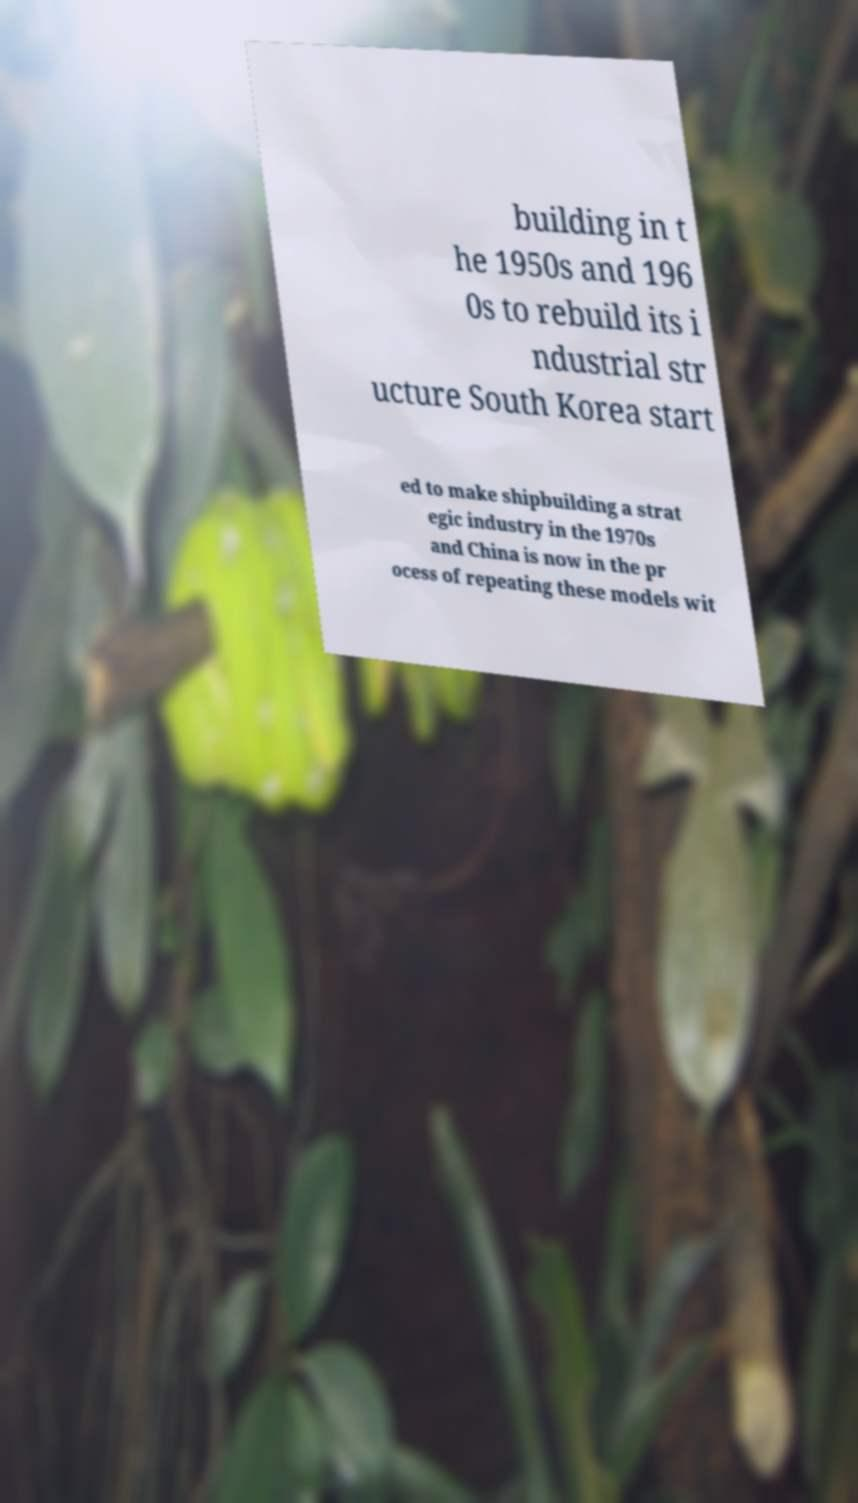For documentation purposes, I need the text within this image transcribed. Could you provide that? building in t he 1950s and 196 0s to rebuild its i ndustrial str ucture South Korea start ed to make shipbuilding a strat egic industry in the 1970s and China is now in the pr ocess of repeating these models wit 